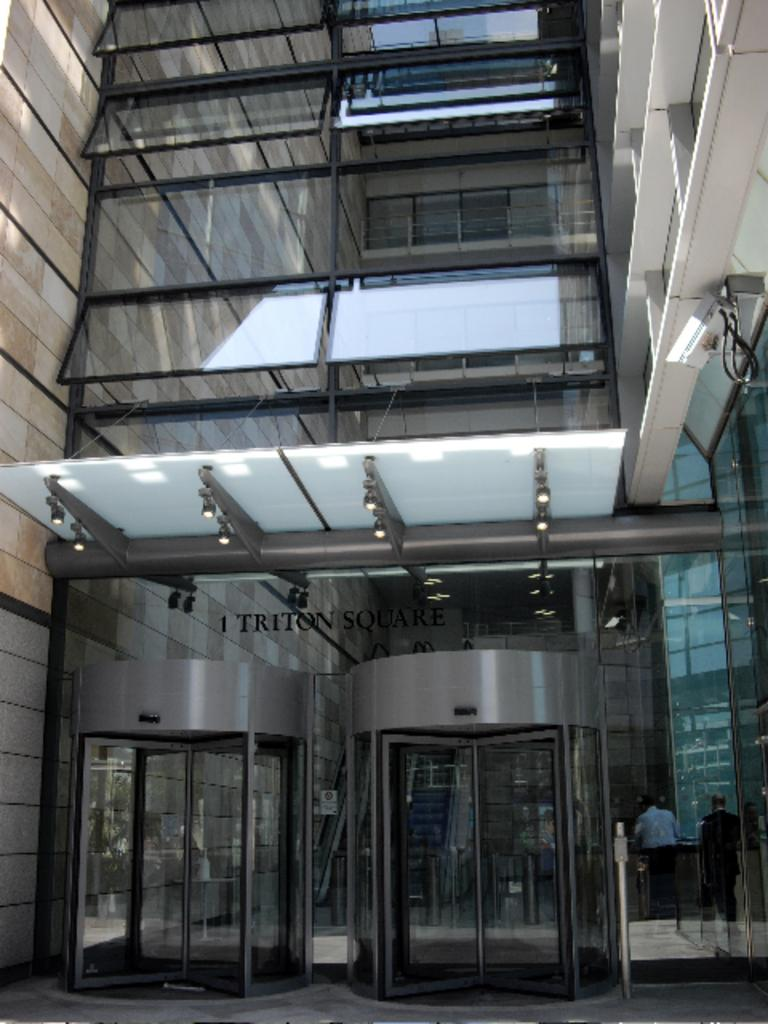What is the main structure in the image? There is a building in the image. What can be seen inside the building? There are people standing in the building. How many ways can people enter the building? There are two entrances to the building. What type of reaction can be seen from the dime in the image? There is no dime present in the image, so it is not possible to observe any reaction from it. 